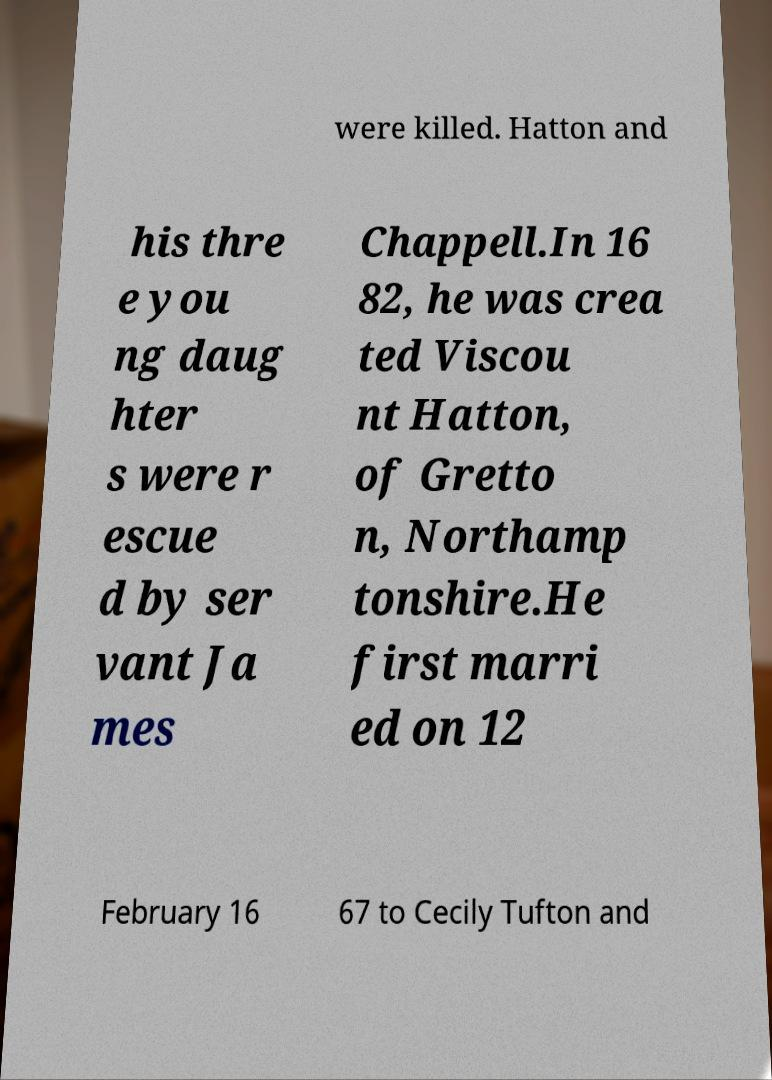Can you read and provide the text displayed in the image?This photo seems to have some interesting text. Can you extract and type it out for me? were killed. Hatton and his thre e you ng daug hter s were r escue d by ser vant Ja mes Chappell.In 16 82, he was crea ted Viscou nt Hatton, of Gretto n, Northamp tonshire.He first marri ed on 12 February 16 67 to Cecily Tufton and 